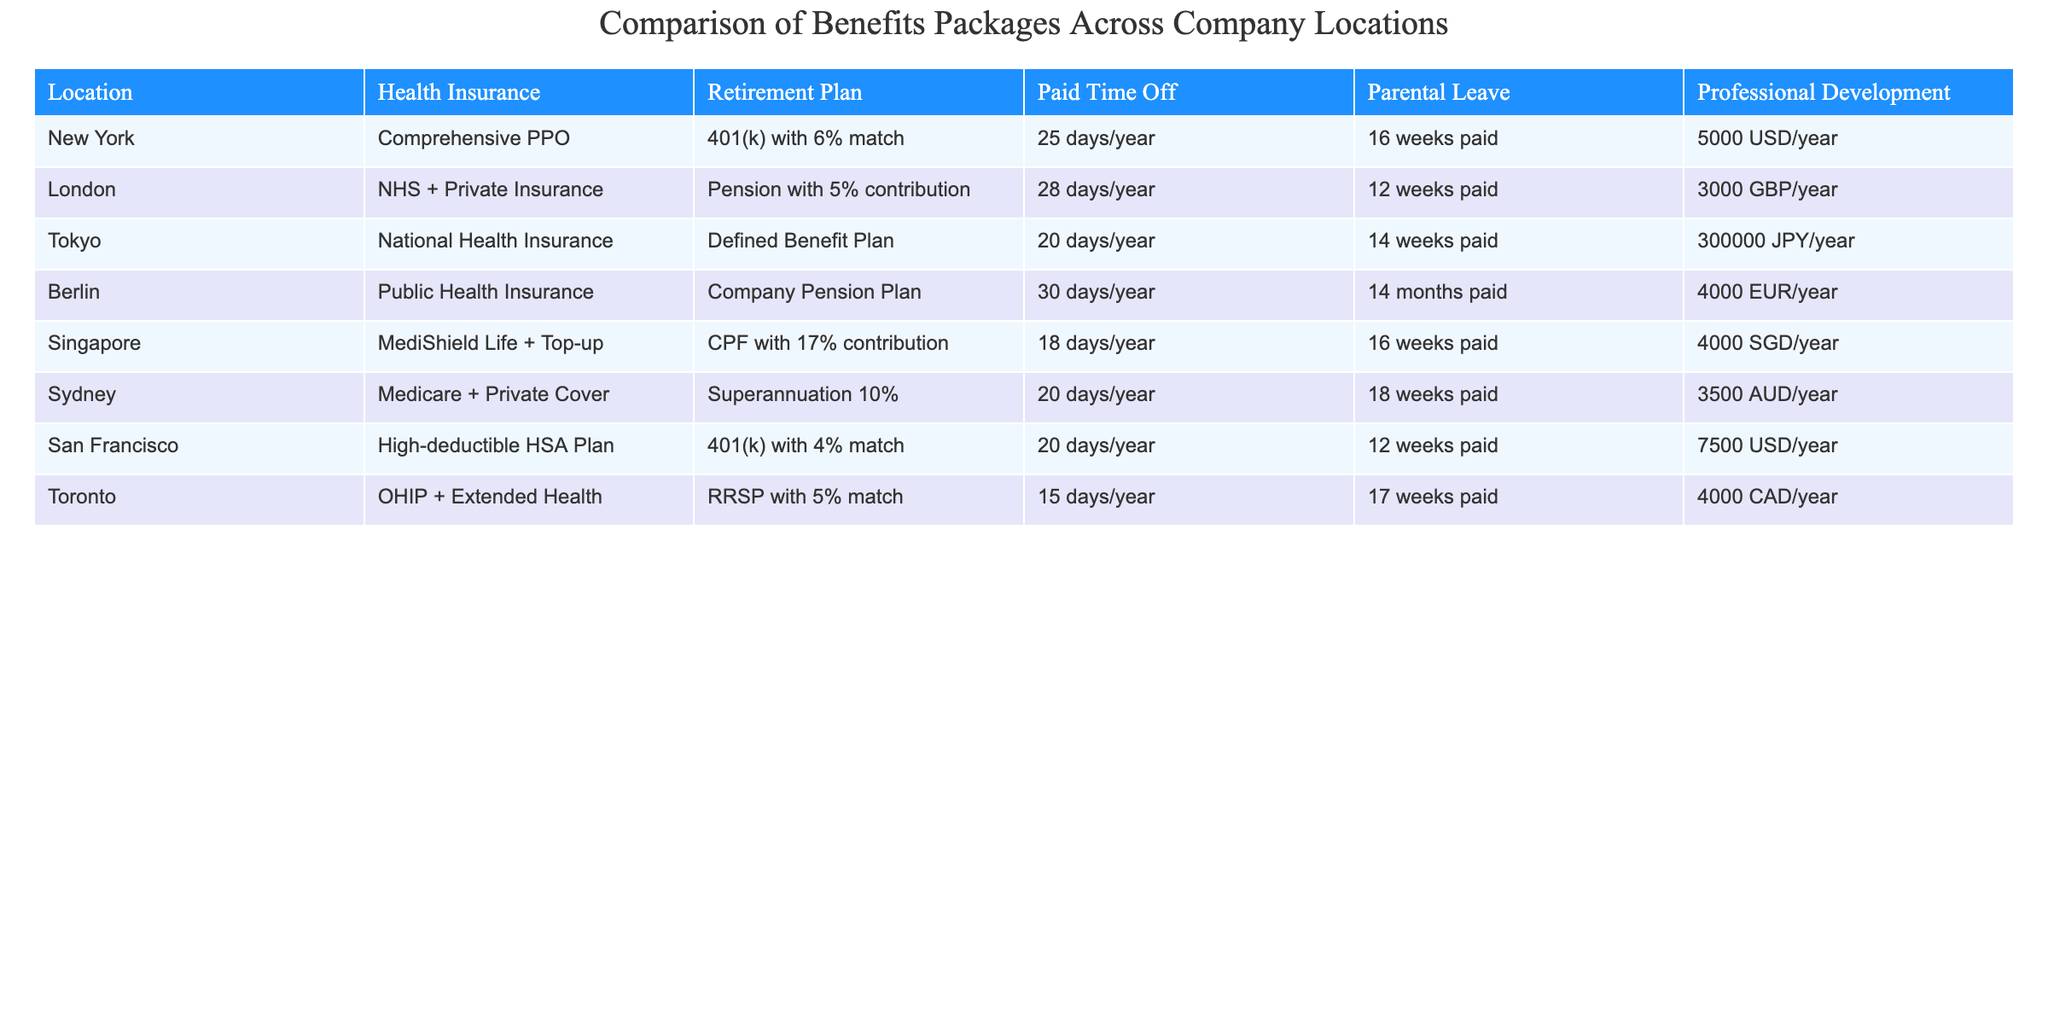What is the paid time off policy in Berlin? The table lists the benefits packages for different locations, and for Berlin, the paid time off is specified as 30 days per year.
Answer: 30 days/year Which city has the longest parental leave? By comparing the parental leave data across the locations, it is evident that Berlin offers the longest parental leave, which is 14 months paid.
Answer: Berlin What is the average number of paid time off days across all locations? To find the average, I will sum the paid time off days from the table: 25 + 28 + 20 + 30 + 18 + 20 + 20 + 15 = 176. There are 8 locations, so the average is 176/8 = 22. This means the average paid time off is 22 days/year.
Answer: 22 days/year Does Tokyo offer a retirement plan? Looking at the retirement plan details in the table, Tokyo has a Defined Benefit Plan listed, indicating that there is indeed a retirement plan offered in that location.
Answer: Yes Which location has the highest amount allocated for professional development? Upon examining the professional development values, San Francisco's allocation is 7500 USD/year, which is the highest compared to the other locations.
Answer: San Francisco 